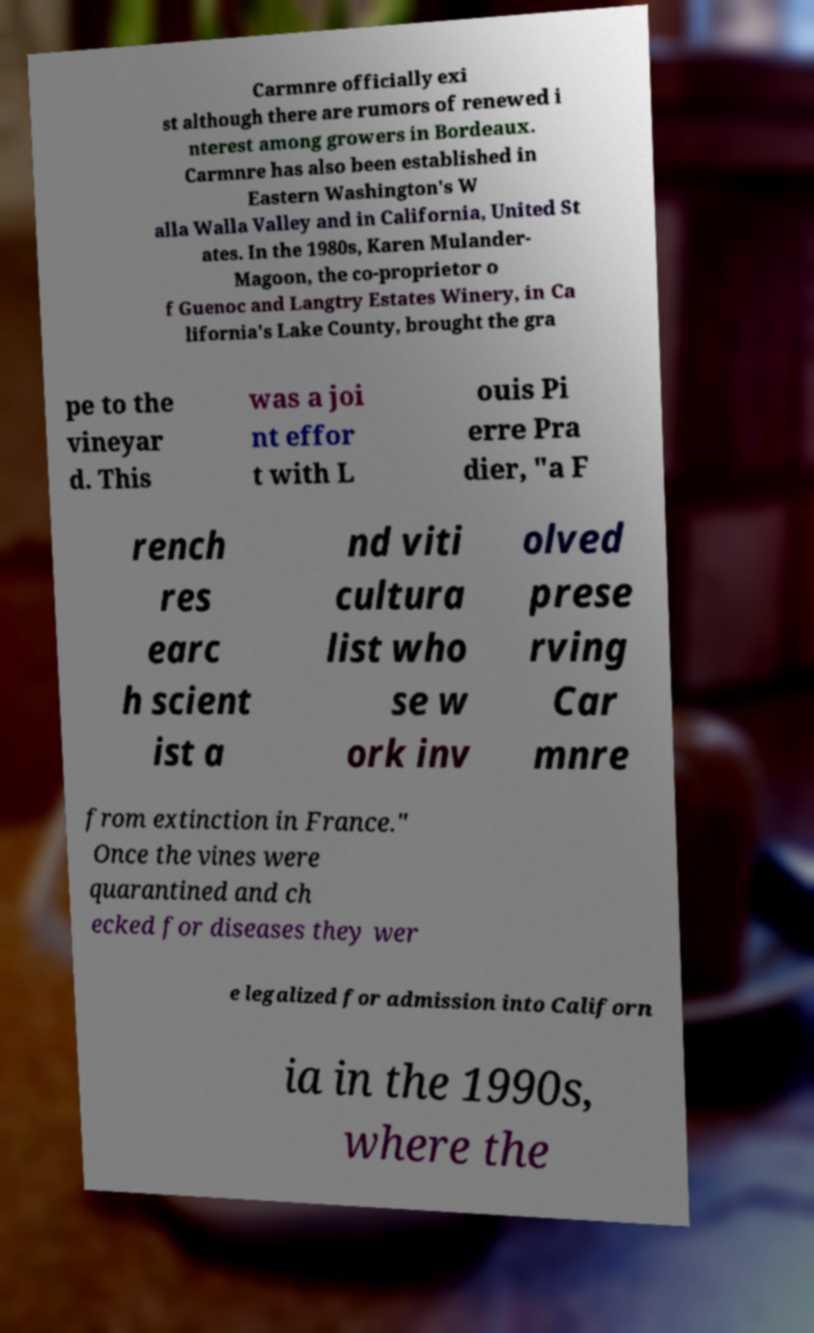For documentation purposes, I need the text within this image transcribed. Could you provide that? Carmnre officially exi st although there are rumors of renewed i nterest among growers in Bordeaux. Carmnre has also been established in Eastern Washington's W alla Walla Valley and in California, United St ates. In the 1980s, Karen Mulander- Magoon, the co-proprietor o f Guenoc and Langtry Estates Winery, in Ca lifornia's Lake County, brought the gra pe to the vineyar d. This was a joi nt effor t with L ouis Pi erre Pra dier, "a F rench res earc h scient ist a nd viti cultura list who se w ork inv olved prese rving Car mnre from extinction in France." Once the vines were quarantined and ch ecked for diseases they wer e legalized for admission into Californ ia in the 1990s, where the 